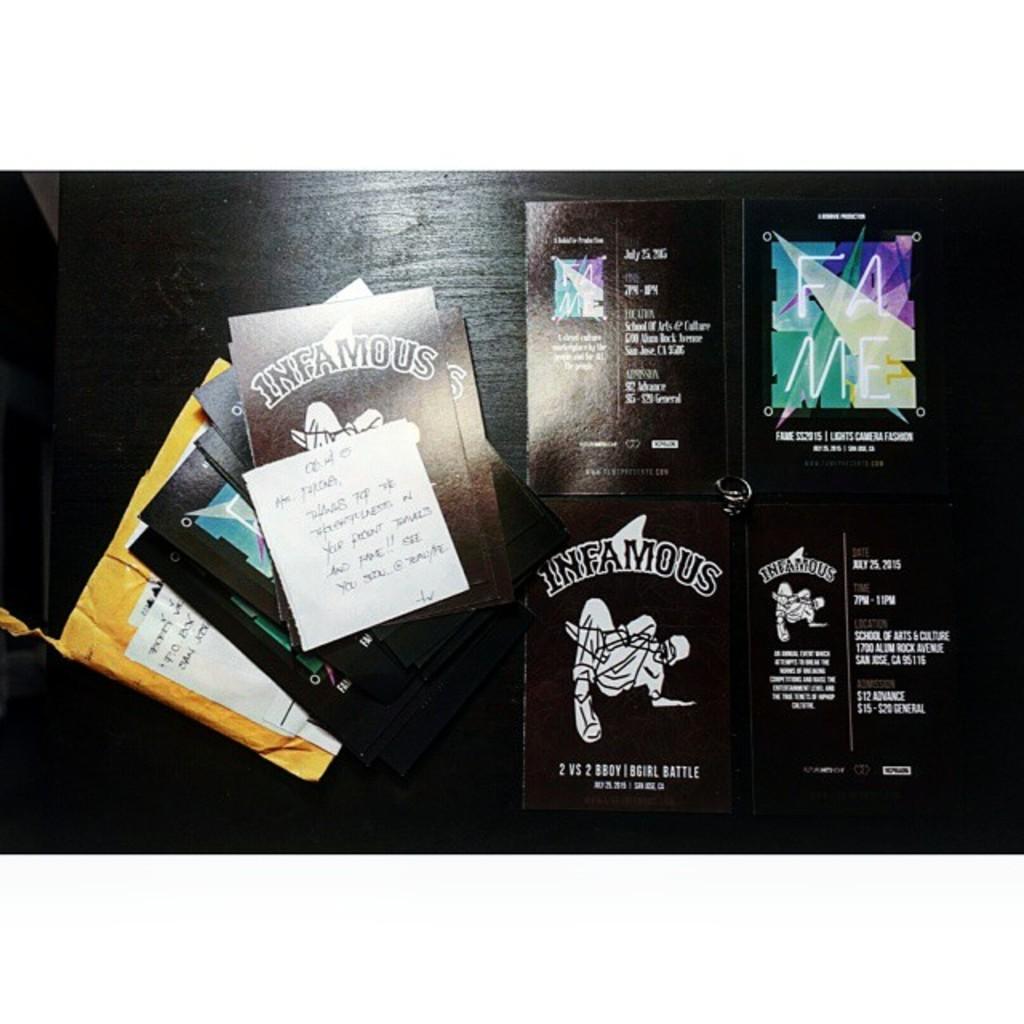What's the brand name of this thing?
Give a very brief answer. Infamous. What four letters are written within the colorful background on the upper right?
Ensure brevity in your answer.  Fame. 